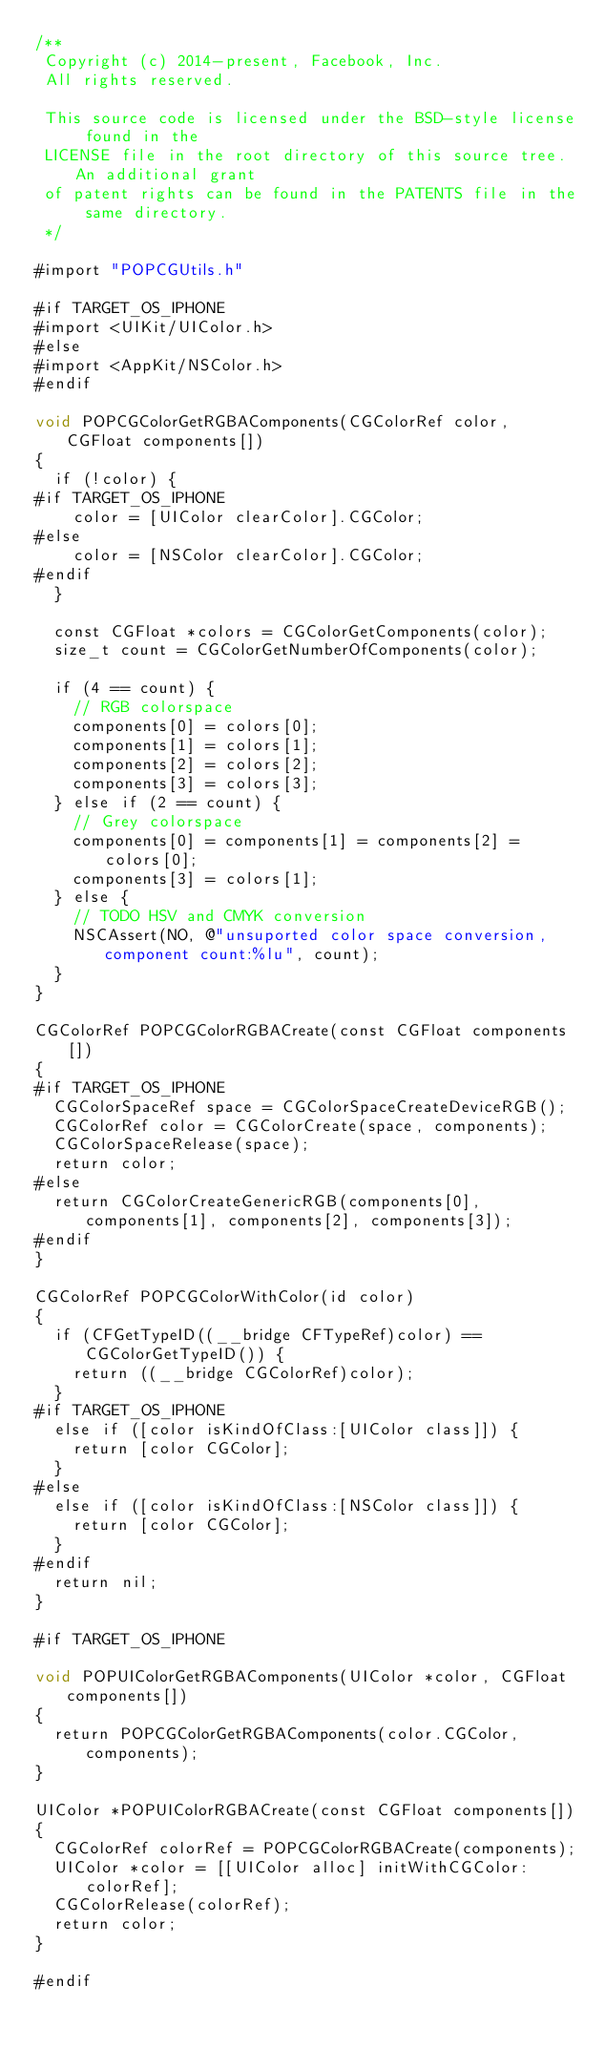Convert code to text. <code><loc_0><loc_0><loc_500><loc_500><_ObjectiveC_>/**
 Copyright (c) 2014-present, Facebook, Inc.
 All rights reserved.
 
 This source code is licensed under the BSD-style license found in the
 LICENSE file in the root directory of this source tree. An additional grant
 of patent rights can be found in the PATENTS file in the same directory.
 */

#import "POPCGUtils.h"

#if TARGET_OS_IPHONE
#import <UIKit/UIColor.h>
#else
#import <AppKit/NSColor.h>
#endif

void POPCGColorGetRGBAComponents(CGColorRef color, CGFloat components[])
{
  if (!color) {
#if TARGET_OS_IPHONE
    color = [UIColor clearColor].CGColor;
#else
    color = [NSColor clearColor].CGColor;
#endif
  }
  
  const CGFloat *colors = CGColorGetComponents(color);
  size_t count = CGColorGetNumberOfComponents(color);
  
  if (4 == count) {
    // RGB colorspace
    components[0] = colors[0];
    components[1] = colors[1];
    components[2] = colors[2];
    components[3] = colors[3];
  } else if (2 == count) {
    // Grey colorspace
    components[0] = components[1] = components[2] = colors[0];
    components[3] = colors[1];
  } else {
    // TODO HSV and CMYK conversion
    NSCAssert(NO, @"unsuported color space conversion, component count:%lu", count);
  }
}

CGColorRef POPCGColorRGBACreate(const CGFloat components[])
{
#if TARGET_OS_IPHONE
  CGColorSpaceRef space = CGColorSpaceCreateDeviceRGB();
  CGColorRef color = CGColorCreate(space, components);
  CGColorSpaceRelease(space);
  return color;
#else
  return CGColorCreateGenericRGB(components[0], components[1], components[2], components[3]);
#endif
}

CGColorRef POPCGColorWithColor(id color)
{
  if (CFGetTypeID((__bridge CFTypeRef)color) == CGColorGetTypeID()) {
    return ((__bridge CGColorRef)color);
  }
#if TARGET_OS_IPHONE
  else if ([color isKindOfClass:[UIColor class]]) {
    return [color CGColor];
  }
#else
  else if ([color isKindOfClass:[NSColor class]]) {
    return [color CGColor];
  }
#endif
  return nil;
}

#if TARGET_OS_IPHONE

void POPUIColorGetRGBAComponents(UIColor *color, CGFloat components[])
{
  return POPCGColorGetRGBAComponents(color.CGColor, components);
}

UIColor *POPUIColorRGBACreate(const CGFloat components[])
{
  CGColorRef colorRef = POPCGColorRGBACreate(components);
  UIColor *color = [[UIColor alloc] initWithCGColor:colorRef];
  CGColorRelease(colorRef);
  return color;
}

#endif

</code> 